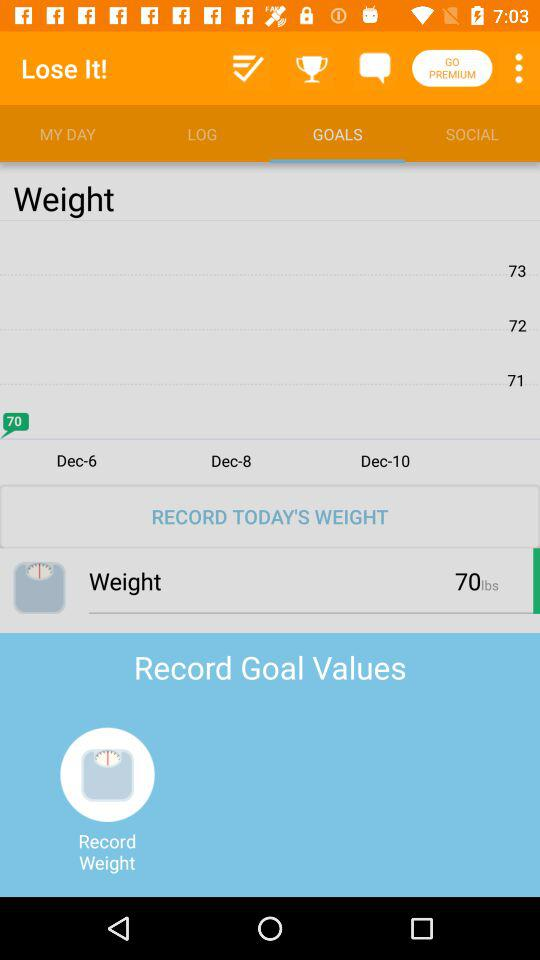What is the difference between the highest and lowest weight recorded on this screen?
Answer the question using a single word or phrase. 3 